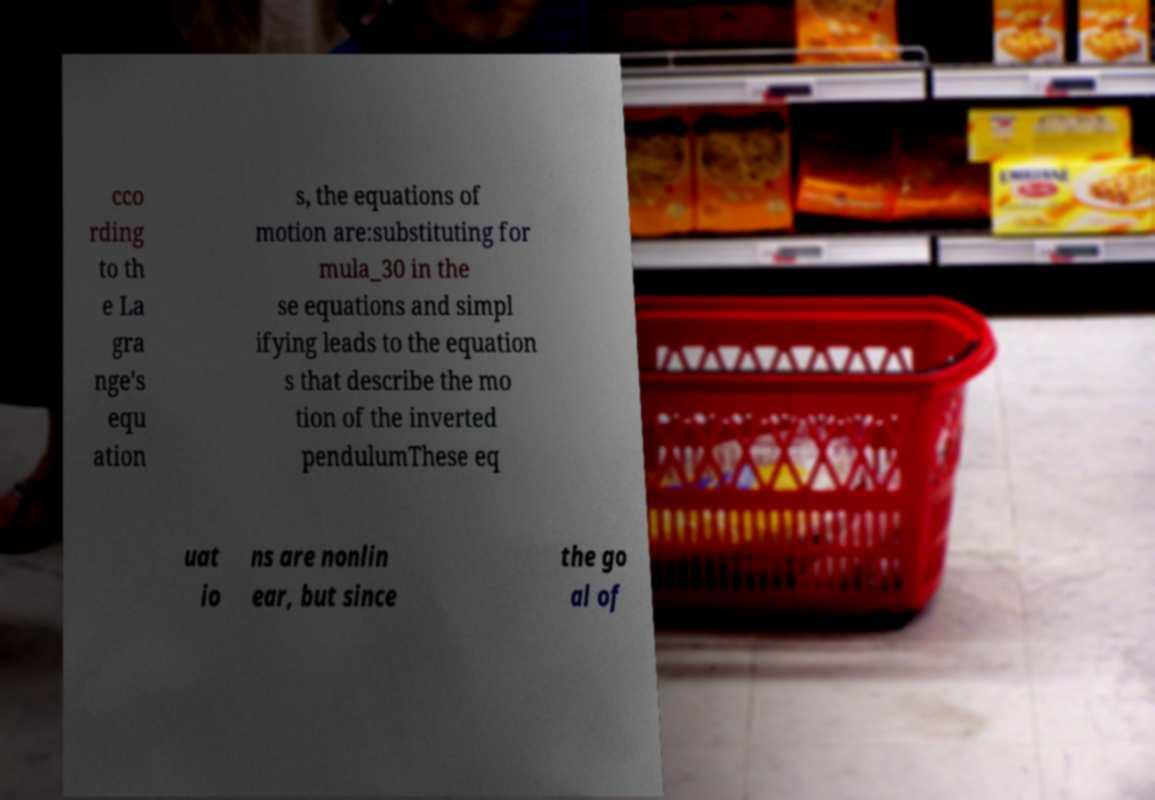Can you accurately transcribe the text from the provided image for me? cco rding to th e La gra nge's equ ation s, the equations of motion are:substituting for mula_30 in the se equations and simpl ifying leads to the equation s that describe the mo tion of the inverted pendulumThese eq uat io ns are nonlin ear, but since the go al of 